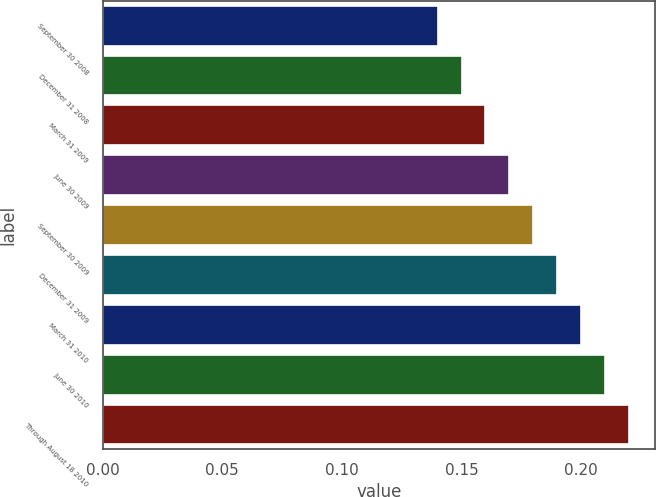Convert chart. <chart><loc_0><loc_0><loc_500><loc_500><bar_chart><fcel>September 30 2008<fcel>December 31 2008<fcel>March 31 2009<fcel>June 30 2009<fcel>September 30 2009<fcel>December 31 2009<fcel>March 31 2010<fcel>June 30 2010<fcel>Through August 18 2010<nl><fcel>0.14<fcel>0.15<fcel>0.16<fcel>0.17<fcel>0.18<fcel>0.19<fcel>0.2<fcel>0.21<fcel>0.22<nl></chart> 